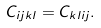Convert formula to latex. <formula><loc_0><loc_0><loc_500><loc_500>C _ { i j k l } = C _ { k l i j } .</formula> 